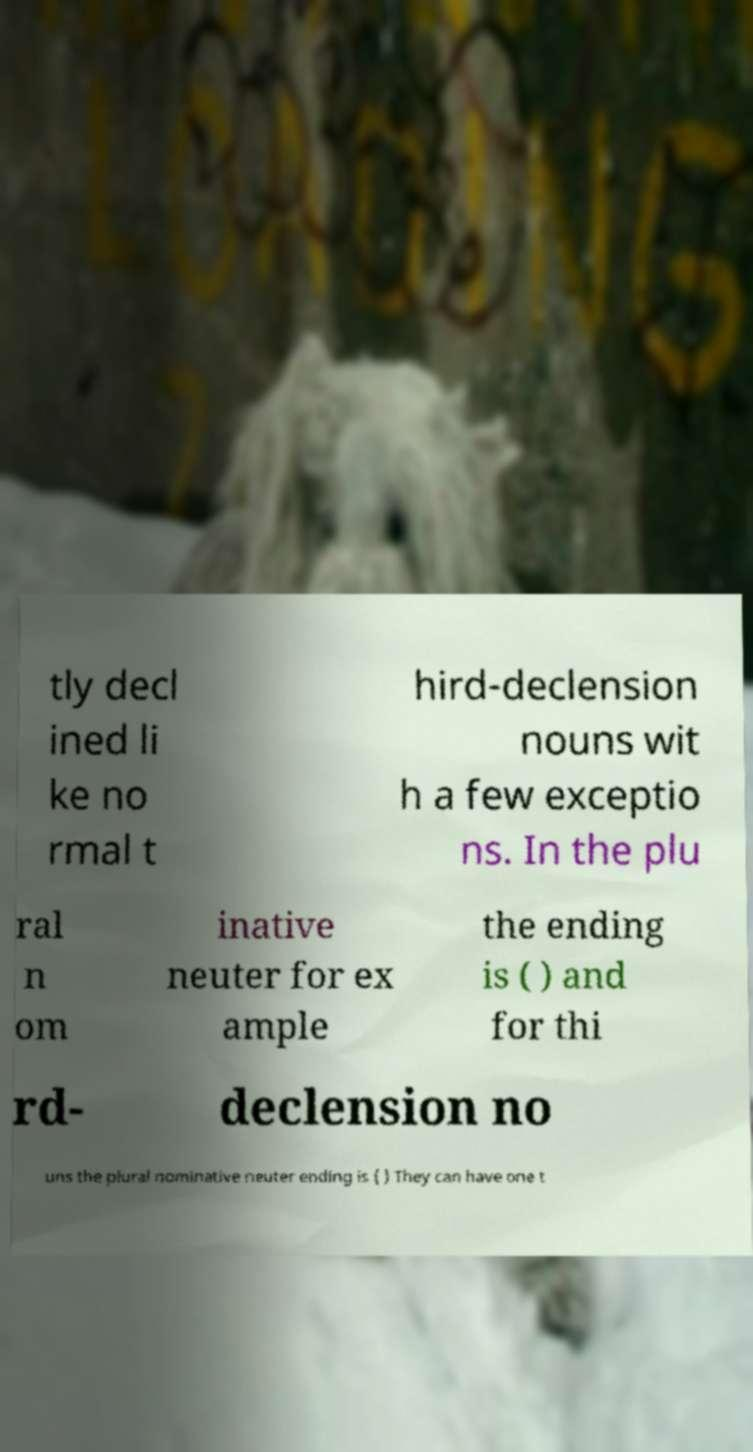Can you read and provide the text displayed in the image?This photo seems to have some interesting text. Can you extract and type it out for me? tly decl ined li ke no rmal t hird-declension nouns wit h a few exceptio ns. In the plu ral n om inative neuter for ex ample the ending is ( ) and for thi rd- declension no uns the plural nominative neuter ending is ( ) They can have one t 